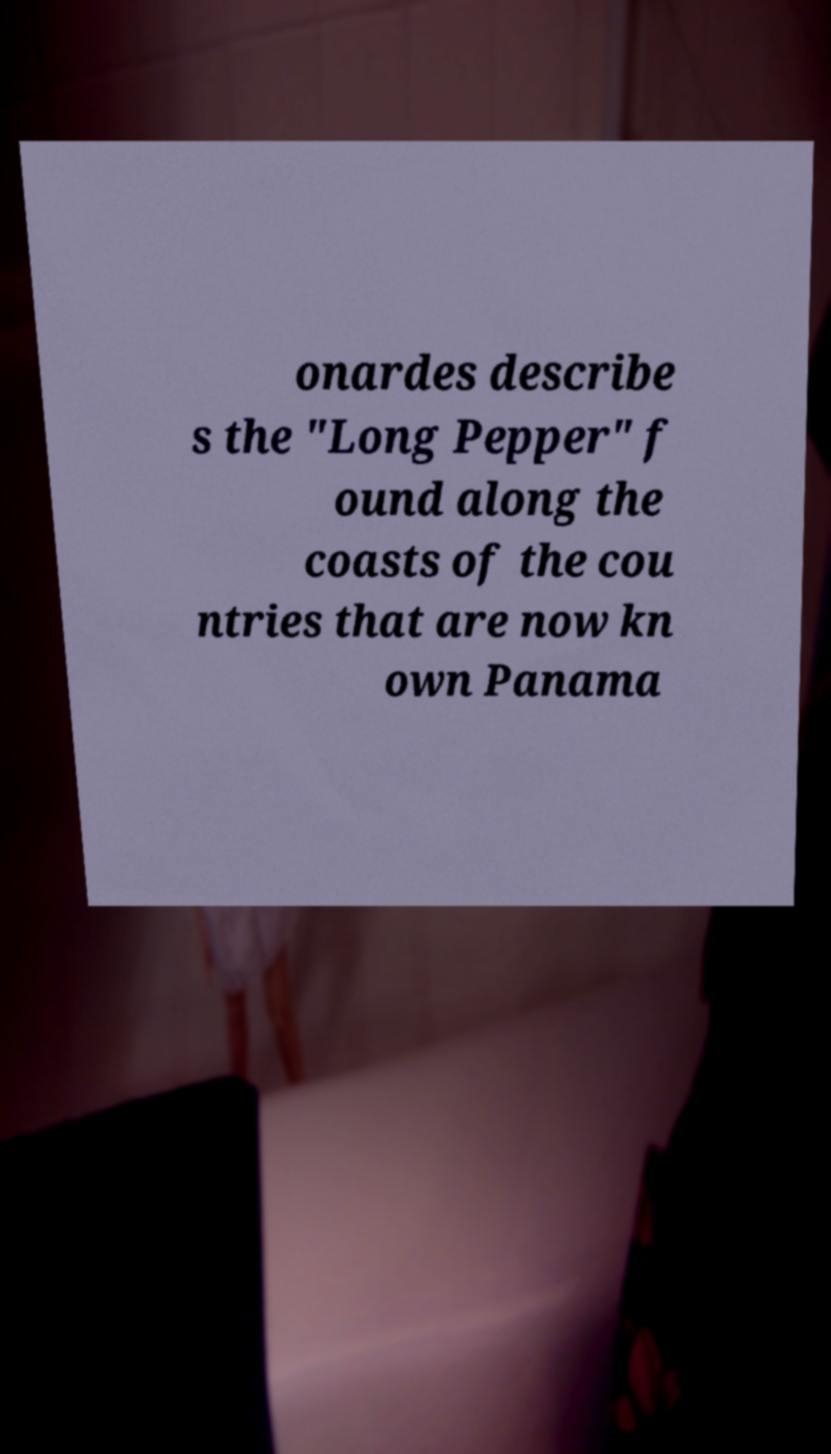For documentation purposes, I need the text within this image transcribed. Could you provide that? onardes describe s the "Long Pepper" f ound along the coasts of the cou ntries that are now kn own Panama 